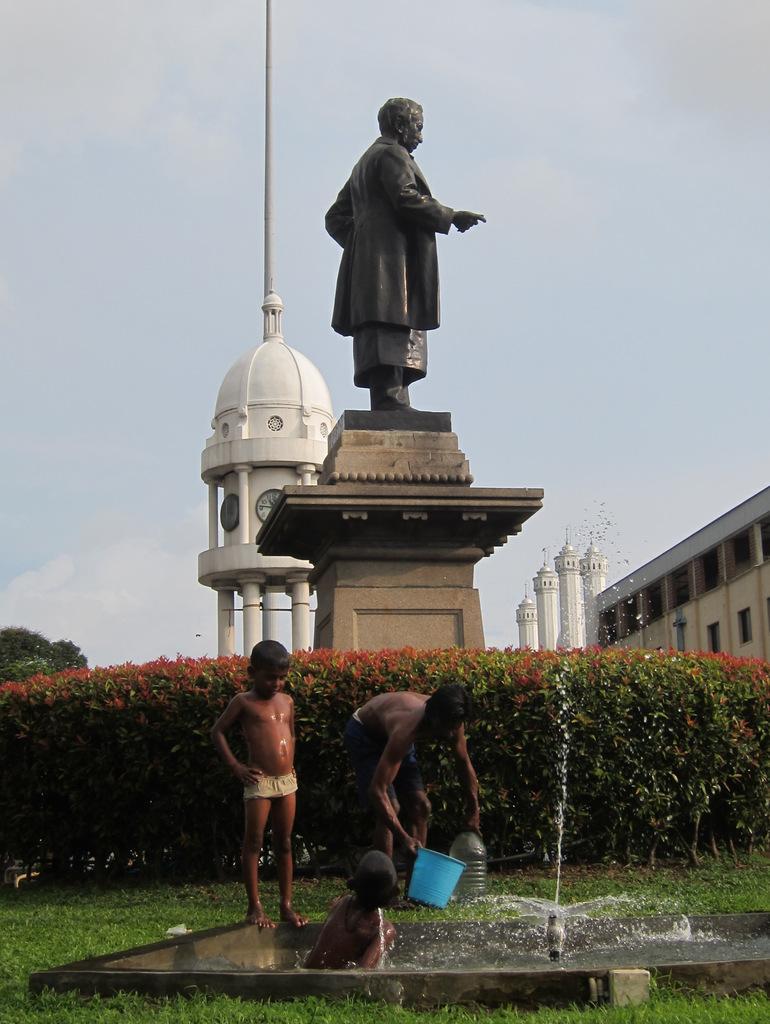Can you describe this image briefly? This is an outside view. At the bottom of the image there is a fountain and I can see three boys near this fountain. On the ground, I can see the grass. At the back of these people there are some plants. In the middle of the image I can see a statue of a person on the pillar. In the background there is a clock tower. On the right side, I can see a building and few pillars. At the top of the image I can see the sky. 